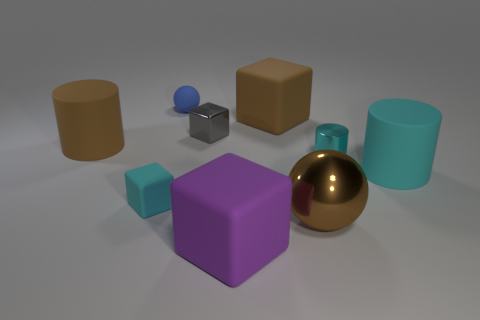Does the rubber block that is on the left side of the purple matte cube have the same size as the tiny blue ball?
Give a very brief answer. Yes. What is the color of the cylinder that is to the right of the cyan rubber block and behind the cyan rubber cylinder?
Ensure brevity in your answer.  Cyan. What number of objects are either cyan rubber cylinders or small objects left of the purple thing?
Your answer should be very brief. 4. What material is the small cyan thing to the right of the sphere that is in front of the small cyan object to the left of the brown ball made of?
Provide a short and direct response. Metal. Are there any other things that are the same material as the purple object?
Make the answer very short. Yes. There is a block to the left of the small blue matte thing; is it the same color as the rubber sphere?
Provide a succinct answer. No. How many blue things are either rubber cylinders or tiny metal cylinders?
Keep it short and to the point. 0. How many other things are the same shape as the cyan metallic thing?
Make the answer very short. 2. Is the tiny gray cube made of the same material as the large purple cube?
Keep it short and to the point. No. The small object that is both right of the tiny cyan matte object and in front of the big brown matte cylinder is made of what material?
Your answer should be very brief. Metal. 